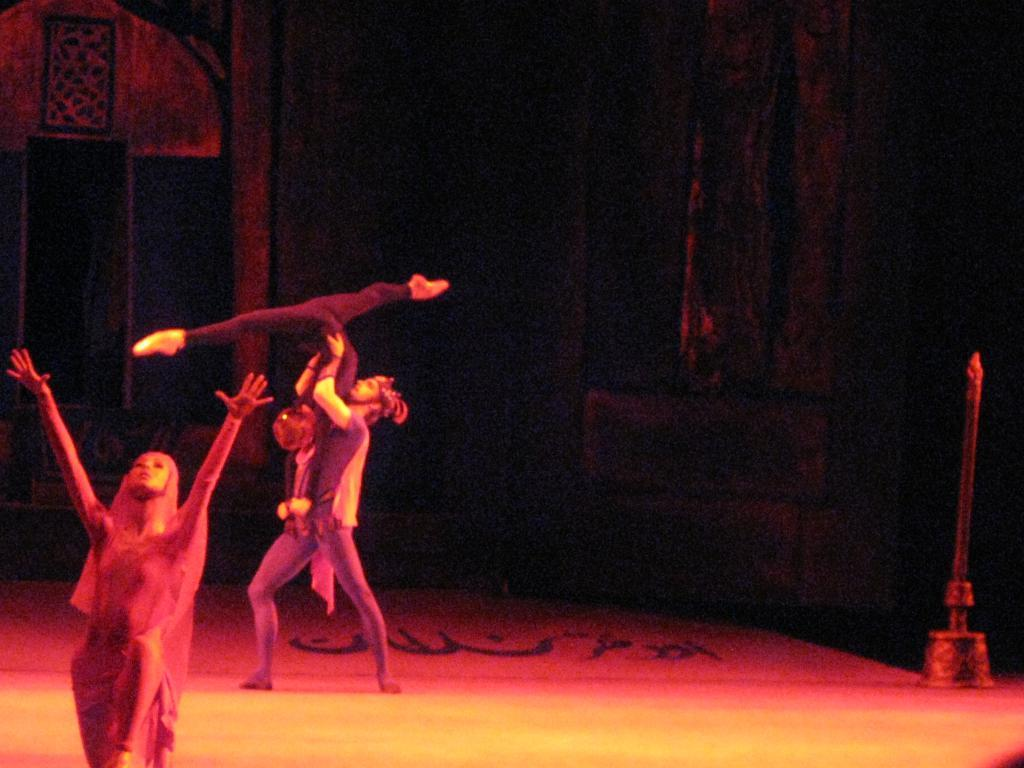What are the three persons in the image doing? The three persons in the image are dancing. Can you describe the object in the image? Unfortunately, the provided facts do not give any information about the object in the image. What is the color of the background in the image? The background of the image is dark. What type of structure can be seen in the image? There is a wall visible in the image. Can you see any blood on the mouth of the person in the image? There is no mention of blood or a person's mouth in the provided facts, so we cannot answer this question based on the image. 